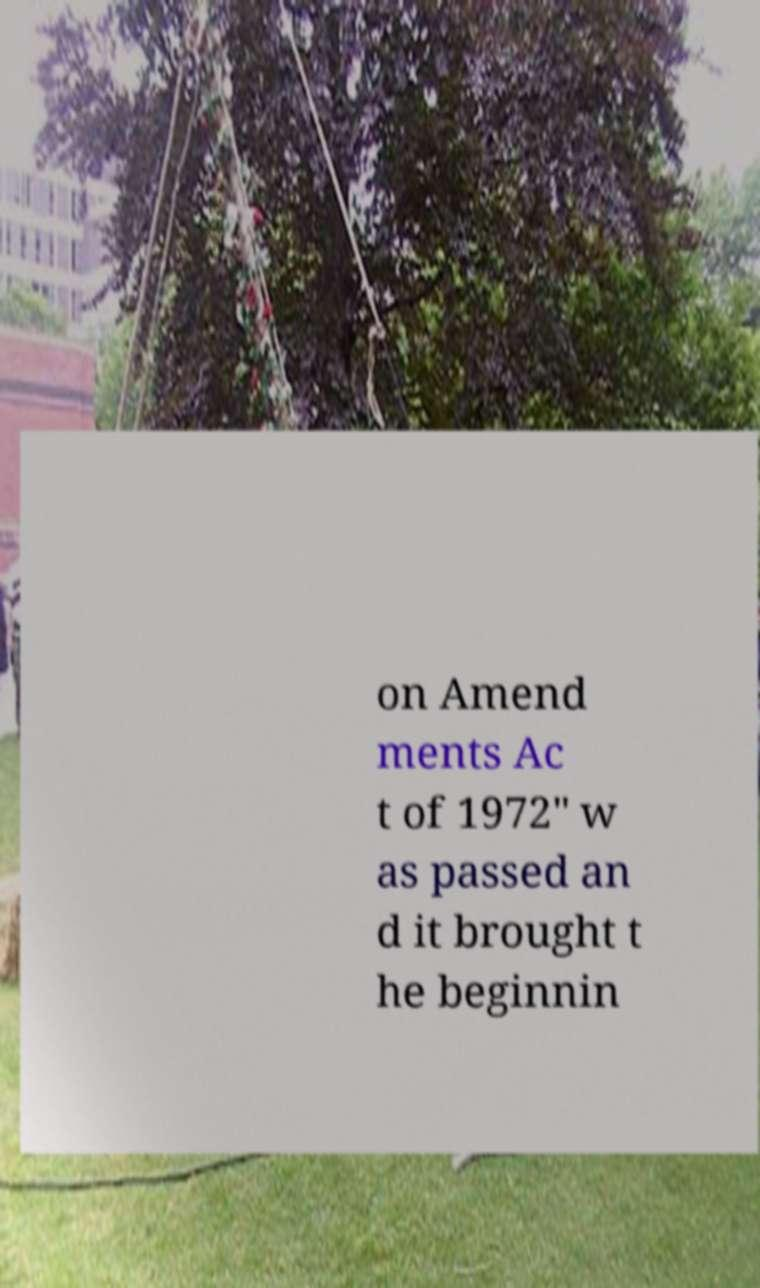There's text embedded in this image that I need extracted. Can you transcribe it verbatim? on Amend ments Ac t of 1972" w as passed an d it brought t he beginnin 